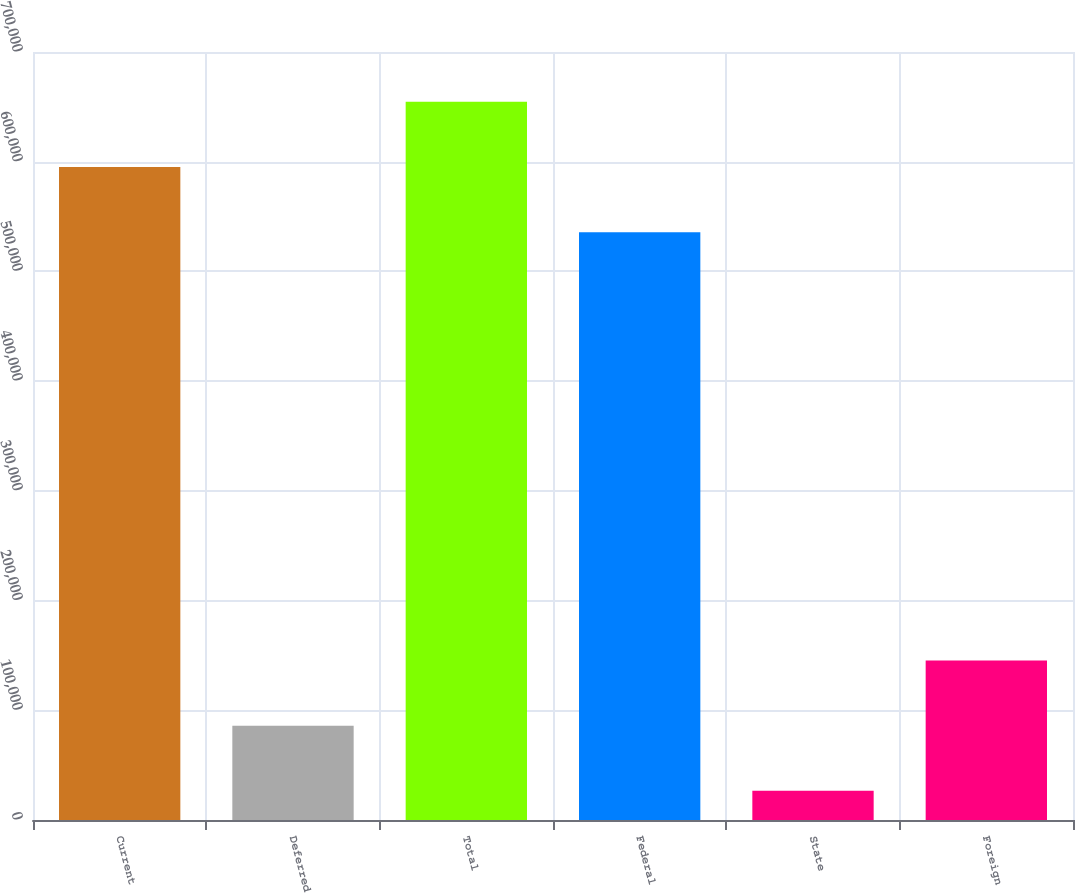Convert chart to OTSL. <chart><loc_0><loc_0><loc_500><loc_500><bar_chart><fcel>Current<fcel>Deferred<fcel>Total<fcel>Federal<fcel>State<fcel>Foreign<nl><fcel>595200<fcel>85983.5<fcel>654622<fcel>535777<fcel>26561<fcel>145406<nl></chart> 